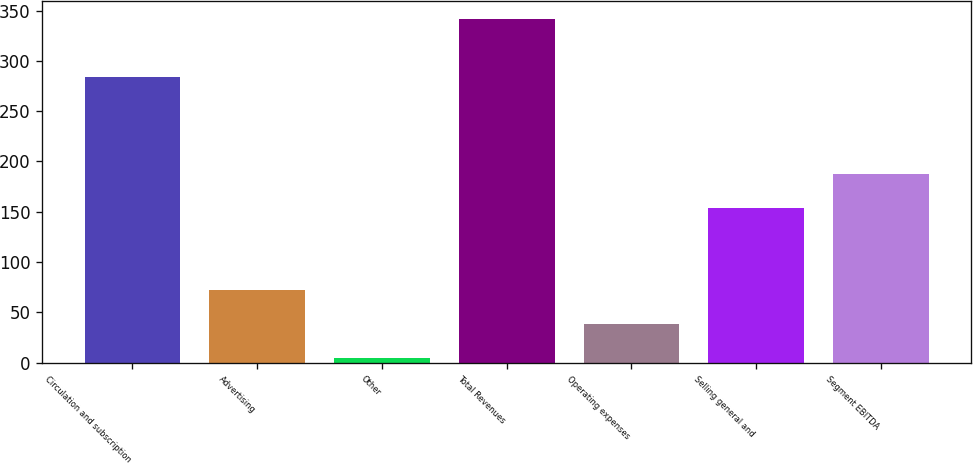<chart> <loc_0><loc_0><loc_500><loc_500><bar_chart><fcel>Circulation and subscription<fcel>Advertising<fcel>Other<fcel>Total Revenues<fcel>Operating expenses<fcel>Selling general and<fcel>Segment EBITDA<nl><fcel>284<fcel>72.4<fcel>5<fcel>342<fcel>38.7<fcel>154<fcel>187.7<nl></chart> 